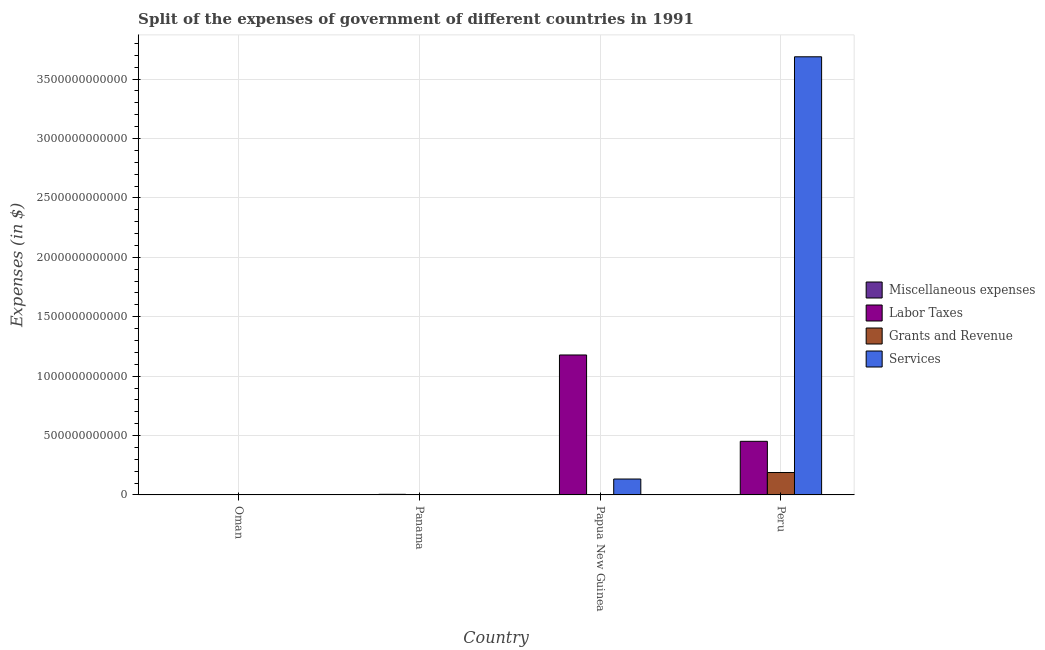How many groups of bars are there?
Your response must be concise. 4. Are the number of bars on each tick of the X-axis equal?
Your response must be concise. Yes. How many bars are there on the 2nd tick from the left?
Your answer should be compact. 4. How many bars are there on the 4th tick from the right?
Provide a short and direct response. 4. What is the label of the 1st group of bars from the left?
Offer a very short reply. Oman. What is the amount spent on grants and revenue in Panama?
Your answer should be compact. 2.28e+07. Across all countries, what is the maximum amount spent on services?
Make the answer very short. 3.69e+12. Across all countries, what is the minimum amount spent on grants and revenue?
Provide a short and direct response. 3.63e+06. In which country was the amount spent on services maximum?
Ensure brevity in your answer.  Peru. In which country was the amount spent on miscellaneous expenses minimum?
Make the answer very short. Oman. What is the total amount spent on miscellaneous expenses in the graph?
Provide a short and direct response. 3.71e+07. What is the difference between the amount spent on grants and revenue in Papua New Guinea and that in Peru?
Offer a very short reply. -1.88e+11. What is the difference between the amount spent on miscellaneous expenses in Oman and the amount spent on grants and revenue in Panama?
Offer a very short reply. -1.91e+07. What is the average amount spent on miscellaneous expenses per country?
Your response must be concise. 9.28e+06. What is the difference between the amount spent on miscellaneous expenses and amount spent on grants and revenue in Papua New Guinea?
Offer a very short reply. -7.04e+08. What is the ratio of the amount spent on miscellaneous expenses in Oman to that in Panama?
Ensure brevity in your answer.  0.16. Is the amount spent on grants and revenue in Panama less than that in Papua New Guinea?
Your answer should be very brief. Yes. What is the difference between the highest and the second highest amount spent on miscellaneous expenses?
Offer a very short reply. 1.84e+07. What is the difference between the highest and the lowest amount spent on services?
Provide a short and direct response. 3.69e+12. Is the sum of the amount spent on services in Oman and Peru greater than the maximum amount spent on labor taxes across all countries?
Your answer should be very brief. Yes. Is it the case that in every country, the sum of the amount spent on labor taxes and amount spent on miscellaneous expenses is greater than the sum of amount spent on services and amount spent on grants and revenue?
Provide a short and direct response. No. What does the 3rd bar from the left in Panama represents?
Ensure brevity in your answer.  Grants and Revenue. What does the 1st bar from the right in Oman represents?
Your response must be concise. Services. Is it the case that in every country, the sum of the amount spent on miscellaneous expenses and amount spent on labor taxes is greater than the amount spent on grants and revenue?
Provide a succinct answer. Yes. How many bars are there?
Provide a short and direct response. 16. Are all the bars in the graph horizontal?
Your response must be concise. No. What is the difference between two consecutive major ticks on the Y-axis?
Provide a short and direct response. 5.00e+11. Where does the legend appear in the graph?
Ensure brevity in your answer.  Center right. How many legend labels are there?
Your response must be concise. 4. What is the title of the graph?
Offer a very short reply. Split of the expenses of government of different countries in 1991. Does "Other expenses" appear as one of the legend labels in the graph?
Provide a short and direct response. No. What is the label or title of the X-axis?
Make the answer very short. Country. What is the label or title of the Y-axis?
Your answer should be compact. Expenses (in $). What is the Expenses (in $) in Miscellaneous expenses in Oman?
Your answer should be compact. 3.70e+06. What is the Expenses (in $) of Labor Taxes in Oman?
Provide a succinct answer. 3.02e+08. What is the Expenses (in $) in Grants and Revenue in Oman?
Provide a short and direct response. 3.63e+06. What is the Expenses (in $) in Services in Oman?
Your response must be concise. 3.08e+07. What is the Expenses (in $) of Miscellaneous expenses in Panama?
Keep it short and to the point. 2.34e+07. What is the Expenses (in $) of Labor Taxes in Panama?
Give a very brief answer. 5.17e+09. What is the Expenses (in $) in Grants and Revenue in Panama?
Provide a succinct answer. 2.28e+07. What is the Expenses (in $) in Services in Panama?
Provide a short and direct response. 7.25e+08. What is the Expenses (in $) of Miscellaneous expenses in Papua New Guinea?
Your answer should be compact. 5.01e+06. What is the Expenses (in $) of Labor Taxes in Papua New Guinea?
Offer a very short reply. 1.18e+12. What is the Expenses (in $) of Grants and Revenue in Papua New Guinea?
Provide a short and direct response. 7.09e+08. What is the Expenses (in $) of Services in Papua New Guinea?
Give a very brief answer. 1.34e+11. What is the Expenses (in $) of Miscellaneous expenses in Peru?
Your answer should be very brief. 5.00e+06. What is the Expenses (in $) in Labor Taxes in Peru?
Keep it short and to the point. 4.51e+11. What is the Expenses (in $) of Grants and Revenue in Peru?
Provide a succinct answer. 1.89e+11. What is the Expenses (in $) of Services in Peru?
Offer a terse response. 3.69e+12. Across all countries, what is the maximum Expenses (in $) in Miscellaneous expenses?
Your answer should be very brief. 2.34e+07. Across all countries, what is the maximum Expenses (in $) of Labor Taxes?
Give a very brief answer. 1.18e+12. Across all countries, what is the maximum Expenses (in $) in Grants and Revenue?
Make the answer very short. 1.89e+11. Across all countries, what is the maximum Expenses (in $) in Services?
Offer a very short reply. 3.69e+12. Across all countries, what is the minimum Expenses (in $) of Miscellaneous expenses?
Provide a short and direct response. 3.70e+06. Across all countries, what is the minimum Expenses (in $) of Labor Taxes?
Your answer should be very brief. 3.02e+08. Across all countries, what is the minimum Expenses (in $) in Grants and Revenue?
Offer a terse response. 3.63e+06. Across all countries, what is the minimum Expenses (in $) in Services?
Keep it short and to the point. 3.08e+07. What is the total Expenses (in $) of Miscellaneous expenses in the graph?
Your answer should be compact. 3.71e+07. What is the total Expenses (in $) in Labor Taxes in the graph?
Offer a terse response. 1.63e+12. What is the total Expenses (in $) of Grants and Revenue in the graph?
Your answer should be very brief. 1.89e+11. What is the total Expenses (in $) in Services in the graph?
Keep it short and to the point. 3.82e+12. What is the difference between the Expenses (in $) of Miscellaneous expenses in Oman and that in Panama?
Offer a very short reply. -1.97e+07. What is the difference between the Expenses (in $) of Labor Taxes in Oman and that in Panama?
Provide a succinct answer. -4.87e+09. What is the difference between the Expenses (in $) in Grants and Revenue in Oman and that in Panama?
Provide a short and direct response. -1.91e+07. What is the difference between the Expenses (in $) of Services in Oman and that in Panama?
Your response must be concise. -6.94e+08. What is the difference between the Expenses (in $) in Miscellaneous expenses in Oman and that in Papua New Guinea?
Give a very brief answer. -1.31e+06. What is the difference between the Expenses (in $) of Labor Taxes in Oman and that in Papua New Guinea?
Your response must be concise. -1.18e+12. What is the difference between the Expenses (in $) of Grants and Revenue in Oman and that in Papua New Guinea?
Make the answer very short. -7.06e+08. What is the difference between the Expenses (in $) of Services in Oman and that in Papua New Guinea?
Offer a terse response. -1.34e+11. What is the difference between the Expenses (in $) in Miscellaneous expenses in Oman and that in Peru?
Your answer should be very brief. -1.30e+06. What is the difference between the Expenses (in $) of Labor Taxes in Oman and that in Peru?
Provide a short and direct response. -4.51e+11. What is the difference between the Expenses (in $) of Grants and Revenue in Oman and that in Peru?
Offer a terse response. -1.89e+11. What is the difference between the Expenses (in $) in Services in Oman and that in Peru?
Make the answer very short. -3.69e+12. What is the difference between the Expenses (in $) of Miscellaneous expenses in Panama and that in Papua New Guinea?
Ensure brevity in your answer.  1.84e+07. What is the difference between the Expenses (in $) in Labor Taxes in Panama and that in Papua New Guinea?
Ensure brevity in your answer.  -1.17e+12. What is the difference between the Expenses (in $) in Grants and Revenue in Panama and that in Papua New Guinea?
Your answer should be compact. -6.87e+08. What is the difference between the Expenses (in $) of Services in Panama and that in Papua New Guinea?
Your answer should be very brief. -1.33e+11. What is the difference between the Expenses (in $) in Miscellaneous expenses in Panama and that in Peru?
Make the answer very short. 1.84e+07. What is the difference between the Expenses (in $) in Labor Taxes in Panama and that in Peru?
Your answer should be compact. -4.46e+11. What is the difference between the Expenses (in $) of Grants and Revenue in Panama and that in Peru?
Offer a very short reply. -1.89e+11. What is the difference between the Expenses (in $) of Services in Panama and that in Peru?
Offer a very short reply. -3.69e+12. What is the difference between the Expenses (in $) in Miscellaneous expenses in Papua New Guinea and that in Peru?
Make the answer very short. 10000. What is the difference between the Expenses (in $) in Labor Taxes in Papua New Guinea and that in Peru?
Make the answer very short. 7.27e+11. What is the difference between the Expenses (in $) of Grants and Revenue in Papua New Guinea and that in Peru?
Your answer should be compact. -1.88e+11. What is the difference between the Expenses (in $) in Services in Papua New Guinea and that in Peru?
Your response must be concise. -3.55e+12. What is the difference between the Expenses (in $) in Miscellaneous expenses in Oman and the Expenses (in $) in Labor Taxes in Panama?
Offer a terse response. -5.17e+09. What is the difference between the Expenses (in $) of Miscellaneous expenses in Oman and the Expenses (in $) of Grants and Revenue in Panama?
Make the answer very short. -1.91e+07. What is the difference between the Expenses (in $) of Miscellaneous expenses in Oman and the Expenses (in $) of Services in Panama?
Your answer should be very brief. -7.22e+08. What is the difference between the Expenses (in $) of Labor Taxes in Oman and the Expenses (in $) of Grants and Revenue in Panama?
Your answer should be very brief. 2.79e+08. What is the difference between the Expenses (in $) in Labor Taxes in Oman and the Expenses (in $) in Services in Panama?
Offer a terse response. -4.23e+08. What is the difference between the Expenses (in $) of Grants and Revenue in Oman and the Expenses (in $) of Services in Panama?
Give a very brief answer. -7.22e+08. What is the difference between the Expenses (in $) in Miscellaneous expenses in Oman and the Expenses (in $) in Labor Taxes in Papua New Guinea?
Offer a terse response. -1.18e+12. What is the difference between the Expenses (in $) of Miscellaneous expenses in Oman and the Expenses (in $) of Grants and Revenue in Papua New Guinea?
Offer a terse response. -7.06e+08. What is the difference between the Expenses (in $) of Miscellaneous expenses in Oman and the Expenses (in $) of Services in Papua New Guinea?
Give a very brief answer. -1.34e+11. What is the difference between the Expenses (in $) of Labor Taxes in Oman and the Expenses (in $) of Grants and Revenue in Papua New Guinea?
Offer a very short reply. -4.08e+08. What is the difference between the Expenses (in $) in Labor Taxes in Oman and the Expenses (in $) in Services in Papua New Guinea?
Your answer should be compact. -1.34e+11. What is the difference between the Expenses (in $) of Grants and Revenue in Oman and the Expenses (in $) of Services in Papua New Guinea?
Your answer should be very brief. -1.34e+11. What is the difference between the Expenses (in $) in Miscellaneous expenses in Oman and the Expenses (in $) in Labor Taxes in Peru?
Make the answer very short. -4.51e+11. What is the difference between the Expenses (in $) of Miscellaneous expenses in Oman and the Expenses (in $) of Grants and Revenue in Peru?
Provide a short and direct response. -1.89e+11. What is the difference between the Expenses (in $) in Miscellaneous expenses in Oman and the Expenses (in $) in Services in Peru?
Keep it short and to the point. -3.69e+12. What is the difference between the Expenses (in $) in Labor Taxes in Oman and the Expenses (in $) in Grants and Revenue in Peru?
Ensure brevity in your answer.  -1.88e+11. What is the difference between the Expenses (in $) in Labor Taxes in Oman and the Expenses (in $) in Services in Peru?
Keep it short and to the point. -3.69e+12. What is the difference between the Expenses (in $) of Grants and Revenue in Oman and the Expenses (in $) of Services in Peru?
Provide a short and direct response. -3.69e+12. What is the difference between the Expenses (in $) in Miscellaneous expenses in Panama and the Expenses (in $) in Labor Taxes in Papua New Guinea?
Keep it short and to the point. -1.18e+12. What is the difference between the Expenses (in $) of Miscellaneous expenses in Panama and the Expenses (in $) of Grants and Revenue in Papua New Guinea?
Give a very brief answer. -6.86e+08. What is the difference between the Expenses (in $) of Miscellaneous expenses in Panama and the Expenses (in $) of Services in Papua New Guinea?
Make the answer very short. -1.34e+11. What is the difference between the Expenses (in $) of Labor Taxes in Panama and the Expenses (in $) of Grants and Revenue in Papua New Guinea?
Give a very brief answer. 4.46e+09. What is the difference between the Expenses (in $) in Labor Taxes in Panama and the Expenses (in $) in Services in Papua New Guinea?
Your answer should be compact. -1.29e+11. What is the difference between the Expenses (in $) of Grants and Revenue in Panama and the Expenses (in $) of Services in Papua New Guinea?
Ensure brevity in your answer.  -1.34e+11. What is the difference between the Expenses (in $) of Miscellaneous expenses in Panama and the Expenses (in $) of Labor Taxes in Peru?
Provide a succinct answer. -4.51e+11. What is the difference between the Expenses (in $) in Miscellaneous expenses in Panama and the Expenses (in $) in Grants and Revenue in Peru?
Provide a succinct answer. -1.89e+11. What is the difference between the Expenses (in $) in Miscellaneous expenses in Panama and the Expenses (in $) in Services in Peru?
Your answer should be compact. -3.69e+12. What is the difference between the Expenses (in $) in Labor Taxes in Panama and the Expenses (in $) in Grants and Revenue in Peru?
Make the answer very short. -1.84e+11. What is the difference between the Expenses (in $) of Labor Taxes in Panama and the Expenses (in $) of Services in Peru?
Your answer should be compact. -3.68e+12. What is the difference between the Expenses (in $) of Grants and Revenue in Panama and the Expenses (in $) of Services in Peru?
Offer a terse response. -3.69e+12. What is the difference between the Expenses (in $) in Miscellaneous expenses in Papua New Guinea and the Expenses (in $) in Labor Taxes in Peru?
Provide a short and direct response. -4.51e+11. What is the difference between the Expenses (in $) in Miscellaneous expenses in Papua New Guinea and the Expenses (in $) in Grants and Revenue in Peru?
Your answer should be compact. -1.89e+11. What is the difference between the Expenses (in $) in Miscellaneous expenses in Papua New Guinea and the Expenses (in $) in Services in Peru?
Keep it short and to the point. -3.69e+12. What is the difference between the Expenses (in $) in Labor Taxes in Papua New Guinea and the Expenses (in $) in Grants and Revenue in Peru?
Keep it short and to the point. 9.89e+11. What is the difference between the Expenses (in $) of Labor Taxes in Papua New Guinea and the Expenses (in $) of Services in Peru?
Make the answer very short. -2.51e+12. What is the difference between the Expenses (in $) of Grants and Revenue in Papua New Guinea and the Expenses (in $) of Services in Peru?
Make the answer very short. -3.69e+12. What is the average Expenses (in $) in Miscellaneous expenses per country?
Provide a succinct answer. 9.28e+06. What is the average Expenses (in $) of Labor Taxes per country?
Make the answer very short. 4.09e+11. What is the average Expenses (in $) of Grants and Revenue per country?
Offer a very short reply. 4.74e+1. What is the average Expenses (in $) of Services per country?
Your answer should be compact. 9.56e+11. What is the difference between the Expenses (in $) of Miscellaneous expenses and Expenses (in $) of Labor Taxes in Oman?
Offer a very short reply. -2.98e+08. What is the difference between the Expenses (in $) of Miscellaneous expenses and Expenses (in $) of Grants and Revenue in Oman?
Your answer should be compact. 7.39e+04. What is the difference between the Expenses (in $) of Miscellaneous expenses and Expenses (in $) of Services in Oman?
Keep it short and to the point. -2.71e+07. What is the difference between the Expenses (in $) of Labor Taxes and Expenses (in $) of Grants and Revenue in Oman?
Keep it short and to the point. 2.98e+08. What is the difference between the Expenses (in $) of Labor Taxes and Expenses (in $) of Services in Oman?
Provide a succinct answer. 2.71e+08. What is the difference between the Expenses (in $) of Grants and Revenue and Expenses (in $) of Services in Oman?
Ensure brevity in your answer.  -2.72e+07. What is the difference between the Expenses (in $) in Miscellaneous expenses and Expenses (in $) in Labor Taxes in Panama?
Offer a terse response. -5.15e+09. What is the difference between the Expenses (in $) of Miscellaneous expenses and Expenses (in $) of Grants and Revenue in Panama?
Ensure brevity in your answer.  6.30e+05. What is the difference between the Expenses (in $) of Miscellaneous expenses and Expenses (in $) of Services in Panama?
Give a very brief answer. -7.02e+08. What is the difference between the Expenses (in $) in Labor Taxes and Expenses (in $) in Grants and Revenue in Panama?
Offer a terse response. 5.15e+09. What is the difference between the Expenses (in $) in Labor Taxes and Expenses (in $) in Services in Panama?
Make the answer very short. 4.44e+09. What is the difference between the Expenses (in $) in Grants and Revenue and Expenses (in $) in Services in Panama?
Offer a terse response. -7.03e+08. What is the difference between the Expenses (in $) of Miscellaneous expenses and Expenses (in $) of Labor Taxes in Papua New Guinea?
Ensure brevity in your answer.  -1.18e+12. What is the difference between the Expenses (in $) in Miscellaneous expenses and Expenses (in $) in Grants and Revenue in Papua New Guinea?
Keep it short and to the point. -7.04e+08. What is the difference between the Expenses (in $) in Miscellaneous expenses and Expenses (in $) in Services in Papua New Guinea?
Make the answer very short. -1.34e+11. What is the difference between the Expenses (in $) in Labor Taxes and Expenses (in $) in Grants and Revenue in Papua New Guinea?
Make the answer very short. 1.18e+12. What is the difference between the Expenses (in $) in Labor Taxes and Expenses (in $) in Services in Papua New Guinea?
Your answer should be very brief. 1.04e+12. What is the difference between the Expenses (in $) in Grants and Revenue and Expenses (in $) in Services in Papua New Guinea?
Ensure brevity in your answer.  -1.33e+11. What is the difference between the Expenses (in $) of Miscellaneous expenses and Expenses (in $) of Labor Taxes in Peru?
Offer a terse response. -4.51e+11. What is the difference between the Expenses (in $) of Miscellaneous expenses and Expenses (in $) of Grants and Revenue in Peru?
Give a very brief answer. -1.89e+11. What is the difference between the Expenses (in $) of Miscellaneous expenses and Expenses (in $) of Services in Peru?
Offer a terse response. -3.69e+12. What is the difference between the Expenses (in $) of Labor Taxes and Expenses (in $) of Grants and Revenue in Peru?
Offer a very short reply. 2.63e+11. What is the difference between the Expenses (in $) in Labor Taxes and Expenses (in $) in Services in Peru?
Ensure brevity in your answer.  -3.24e+12. What is the difference between the Expenses (in $) of Grants and Revenue and Expenses (in $) of Services in Peru?
Make the answer very short. -3.50e+12. What is the ratio of the Expenses (in $) of Miscellaneous expenses in Oman to that in Panama?
Your response must be concise. 0.16. What is the ratio of the Expenses (in $) in Labor Taxes in Oman to that in Panama?
Offer a terse response. 0.06. What is the ratio of the Expenses (in $) of Grants and Revenue in Oman to that in Panama?
Your response must be concise. 0.16. What is the ratio of the Expenses (in $) in Services in Oman to that in Panama?
Provide a succinct answer. 0.04. What is the ratio of the Expenses (in $) of Miscellaneous expenses in Oman to that in Papua New Guinea?
Make the answer very short. 0.74. What is the ratio of the Expenses (in $) of Grants and Revenue in Oman to that in Papua New Guinea?
Your answer should be compact. 0.01. What is the ratio of the Expenses (in $) in Services in Oman to that in Papua New Guinea?
Keep it short and to the point. 0. What is the ratio of the Expenses (in $) of Miscellaneous expenses in Oman to that in Peru?
Make the answer very short. 0.74. What is the ratio of the Expenses (in $) of Labor Taxes in Oman to that in Peru?
Give a very brief answer. 0. What is the ratio of the Expenses (in $) of Grants and Revenue in Oman to that in Peru?
Your answer should be compact. 0. What is the ratio of the Expenses (in $) in Services in Oman to that in Peru?
Your answer should be compact. 0. What is the ratio of the Expenses (in $) in Miscellaneous expenses in Panama to that in Papua New Guinea?
Your answer should be compact. 4.67. What is the ratio of the Expenses (in $) in Labor Taxes in Panama to that in Papua New Guinea?
Your response must be concise. 0. What is the ratio of the Expenses (in $) in Grants and Revenue in Panama to that in Papua New Guinea?
Offer a terse response. 0.03. What is the ratio of the Expenses (in $) in Services in Panama to that in Papua New Guinea?
Provide a short and direct response. 0.01. What is the ratio of the Expenses (in $) in Miscellaneous expenses in Panama to that in Peru?
Provide a succinct answer. 4.68. What is the ratio of the Expenses (in $) in Labor Taxes in Panama to that in Peru?
Offer a very short reply. 0.01. What is the ratio of the Expenses (in $) of Miscellaneous expenses in Papua New Guinea to that in Peru?
Offer a terse response. 1. What is the ratio of the Expenses (in $) of Labor Taxes in Papua New Guinea to that in Peru?
Keep it short and to the point. 2.61. What is the ratio of the Expenses (in $) in Grants and Revenue in Papua New Guinea to that in Peru?
Offer a terse response. 0. What is the ratio of the Expenses (in $) of Services in Papua New Guinea to that in Peru?
Make the answer very short. 0.04. What is the difference between the highest and the second highest Expenses (in $) of Miscellaneous expenses?
Provide a short and direct response. 1.84e+07. What is the difference between the highest and the second highest Expenses (in $) of Labor Taxes?
Keep it short and to the point. 7.27e+11. What is the difference between the highest and the second highest Expenses (in $) in Grants and Revenue?
Give a very brief answer. 1.88e+11. What is the difference between the highest and the second highest Expenses (in $) in Services?
Offer a very short reply. 3.55e+12. What is the difference between the highest and the lowest Expenses (in $) in Miscellaneous expenses?
Your response must be concise. 1.97e+07. What is the difference between the highest and the lowest Expenses (in $) in Labor Taxes?
Make the answer very short. 1.18e+12. What is the difference between the highest and the lowest Expenses (in $) in Grants and Revenue?
Provide a succinct answer. 1.89e+11. What is the difference between the highest and the lowest Expenses (in $) in Services?
Provide a succinct answer. 3.69e+12. 